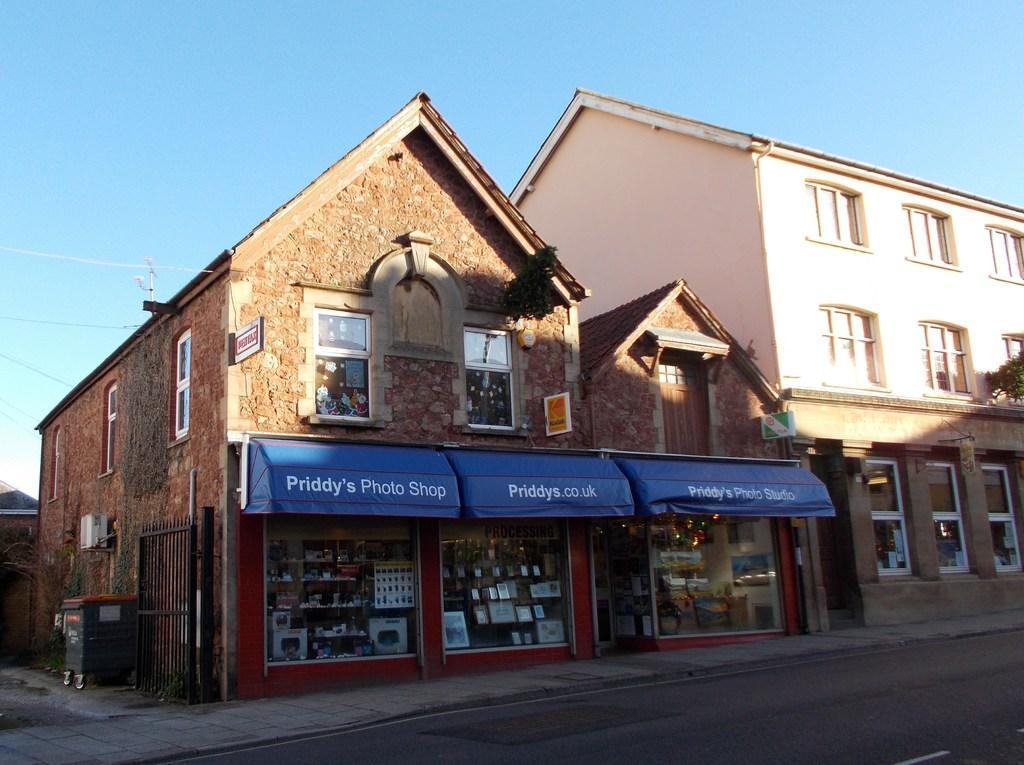Please provide a concise description of this image. In this image there is a shop having few objects on the rocks which are inside the shop. Beside the shop there is a building. Right side there is a tree. Left side there is a dustbin on the pavement. Top of the image there is sky. 